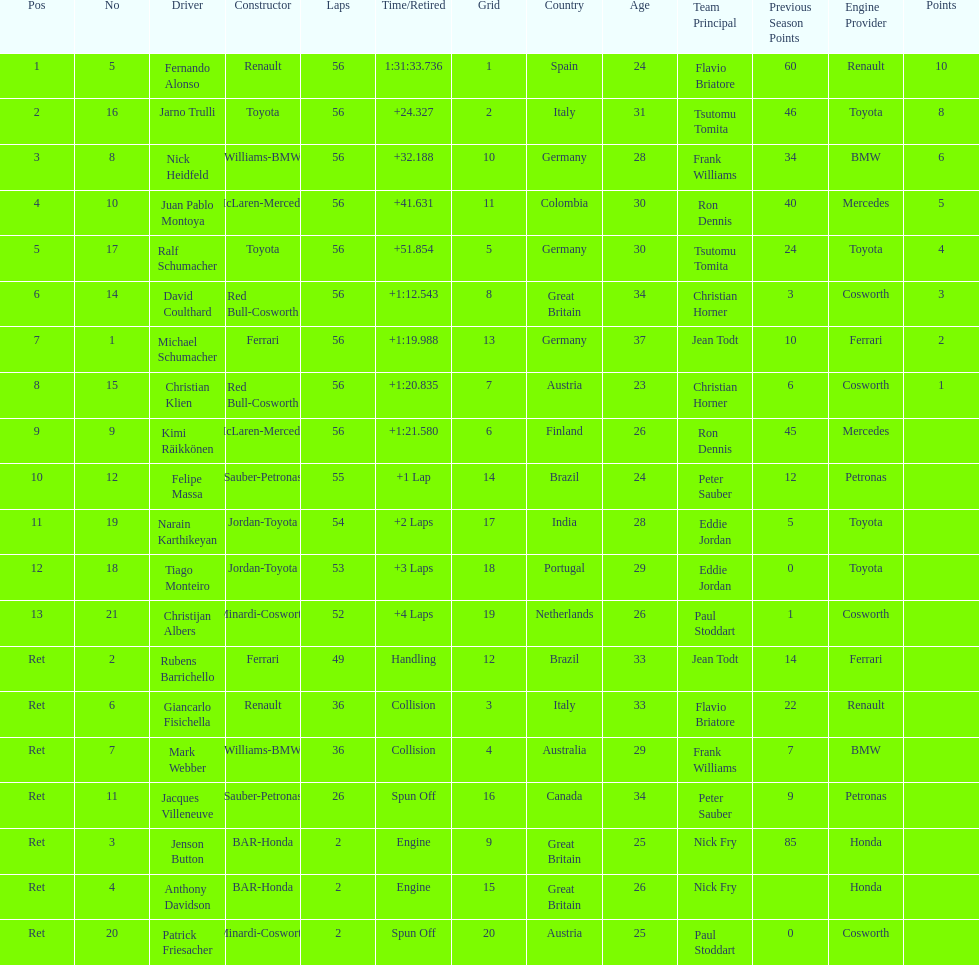How many drivers ended the race early because of engine problems? 2. 